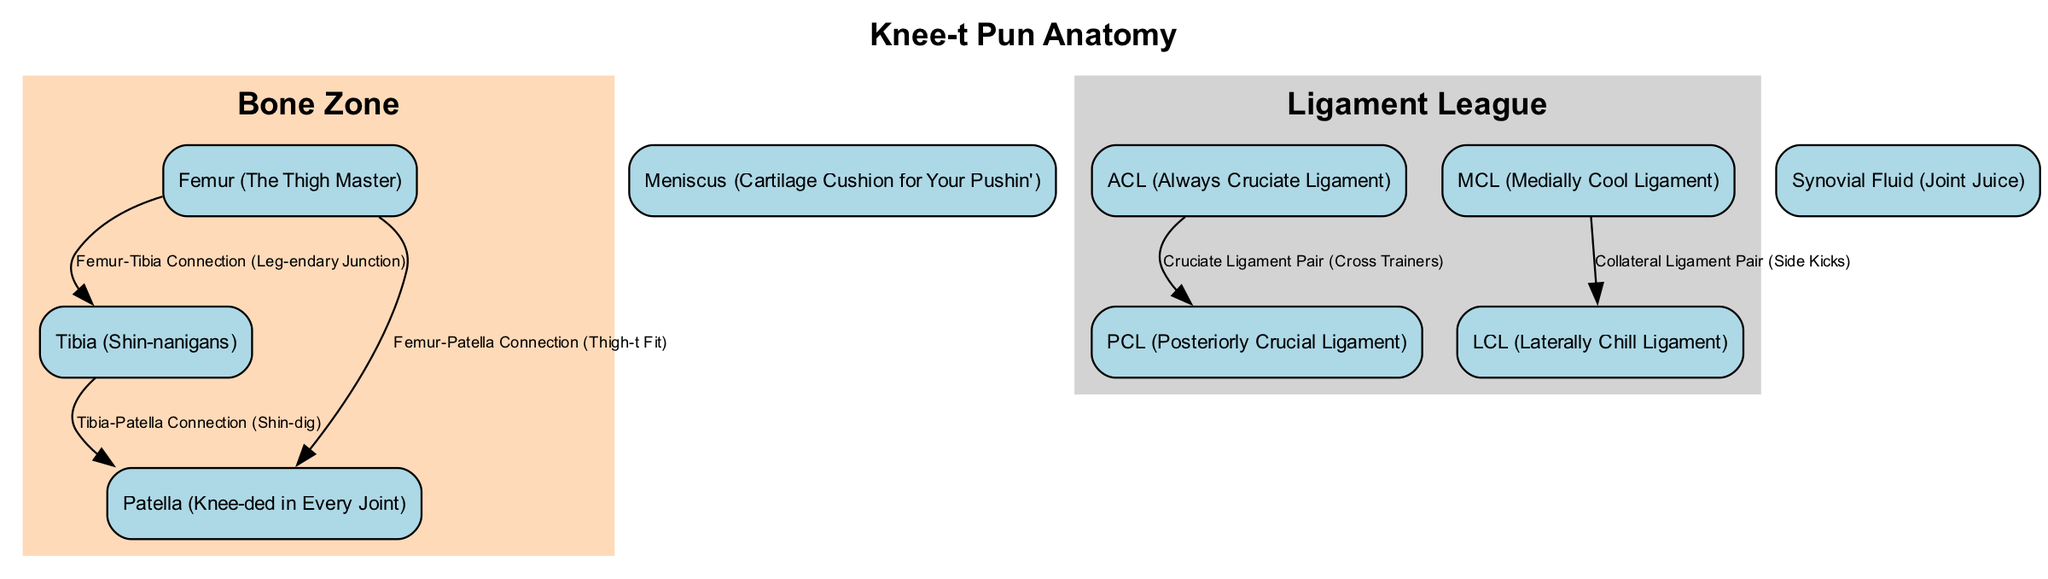What is the title of the diagram? The title of the diagram is stated at the top, labeled as "Knee-t Pun Anatomy."
Answer: Knee-t Pun Anatomy How many bones are represented in the diagram? The diagram features three bones: Femur, Tibia, and Patella.
Answer: 3 What is the connection between the Femur and Patella labeled as? The diagram shows the connection between the Femur and Patella labeled as "Femur-Patella Connection (Thigh-t Fit)."
Answer: Femur-Patella Connection (Thigh-t Fit) Which ligament is labeled “Always Cruciate Ligament”? The diagram specifically labels one ligament as "ACL (Always Cruciate Ligament)."
Answer: ACL (Always Cruciate Ligament) What do the "Medially Cool Ligament" and "Laterally Chill Ligament" have in common? Both the Medially Cool Ligament (MCL) and Laterally Chill Ligament (LCL) are categorized as collateral ligaments that connect bones on either side of the knee joint.
Answer: They are collateral ligaments What type of fluid is labeled as "Joint Juice"? The diagram identifies the type of fluid present in the knee joint as "Synovial Fluid (Joint Juice)."
Answer: Synovial Fluid (Joint Juice) How are the ACL and PCL described in relation to each other? The ACL and PCL are portrayed as a pair within the diagram, labeled together as "Cruciate Ligament Pair (Cross Trainers)."
Answer: Cruciate Ligament Pair (Cross Trainers) Which bone has a humorous label referencing a fitness program? The Femur is humorously labeled as "The Thigh Master," referencing a popular fitness program.
Answer: The Thigh Master 